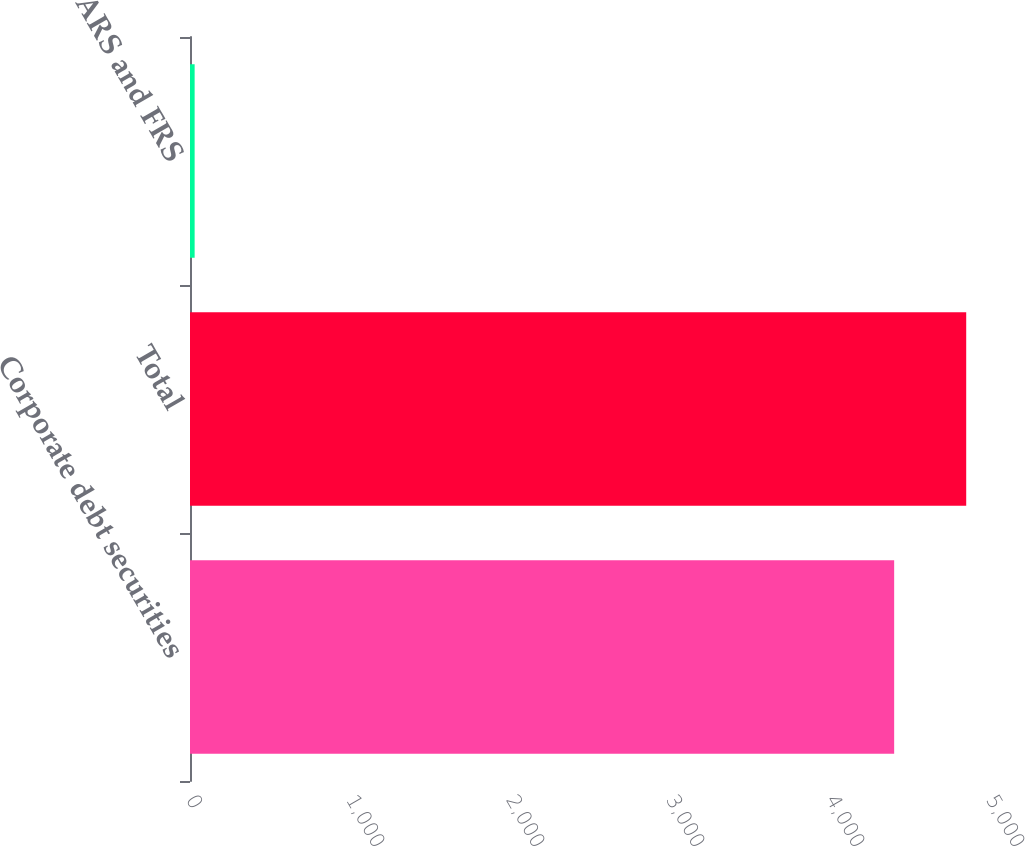Convert chart. <chart><loc_0><loc_0><loc_500><loc_500><bar_chart><fcel>Corporate debt securities<fcel>Total<fcel>ARS and FRS<nl><fcel>4401<fcel>4851.3<fcel>29<nl></chart> 